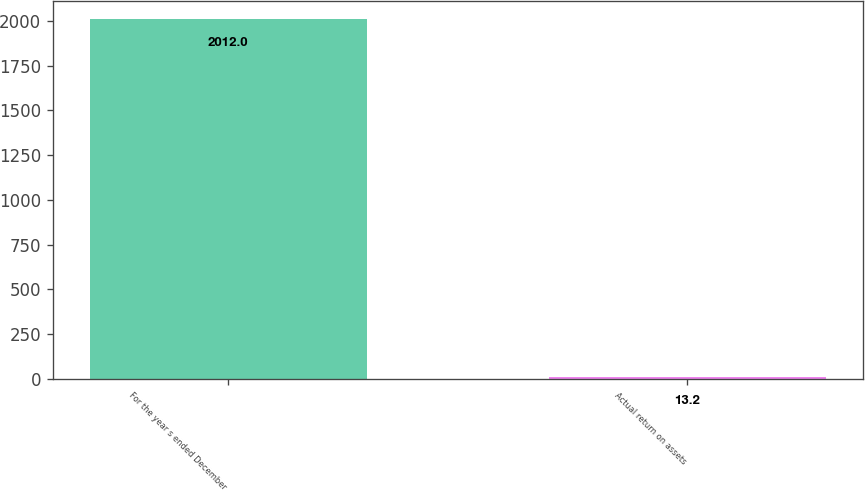Convert chart. <chart><loc_0><loc_0><loc_500><loc_500><bar_chart><fcel>For the year s ended December<fcel>Actual return on assets<nl><fcel>2012<fcel>13.2<nl></chart> 